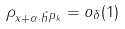<formula> <loc_0><loc_0><loc_500><loc_500>\| \rho _ { x + \alpha \cdot \vec { h } } \| _ { p _ { k } } = o _ { \delta } ( 1 )</formula> 